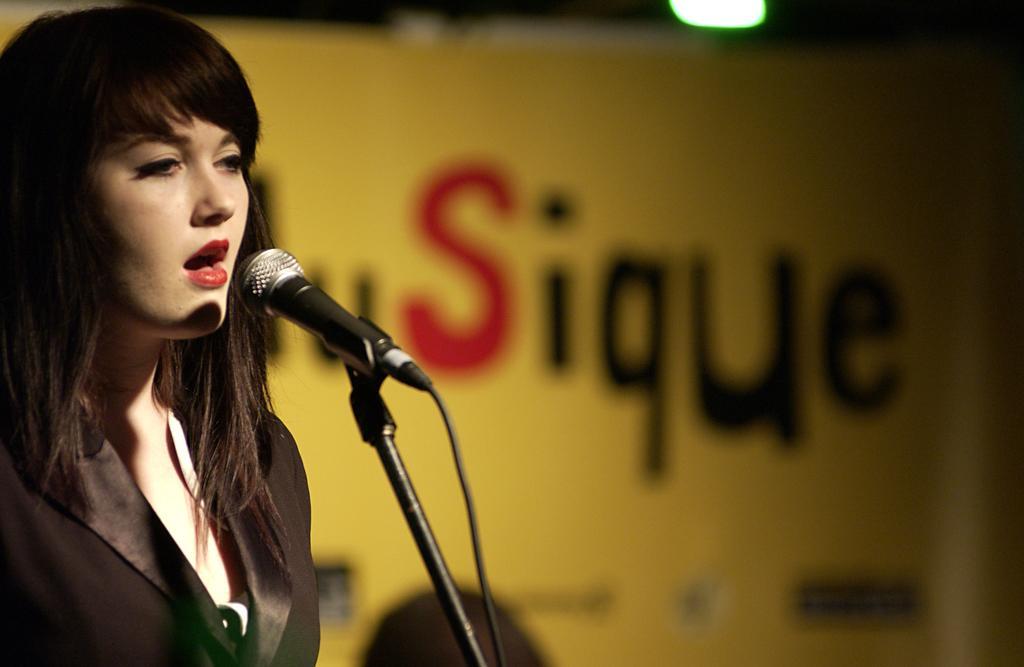How would you summarize this image in a sentence or two? In the picture we can see a woman standing and singing a song in the microphone and she is wearing a black color blazer, in the background, we can see a board which is yellow in color with something written on it as sique. 